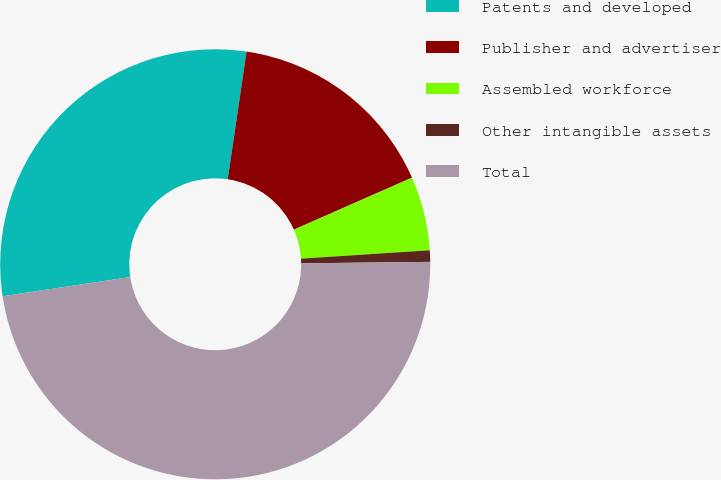Convert chart to OTSL. <chart><loc_0><loc_0><loc_500><loc_500><pie_chart><fcel>Patents and developed<fcel>Publisher and advertiser<fcel>Assembled workforce<fcel>Other intangible assets<fcel>Total<nl><fcel>29.7%<fcel>16.07%<fcel>5.56%<fcel>0.86%<fcel>47.8%<nl></chart> 